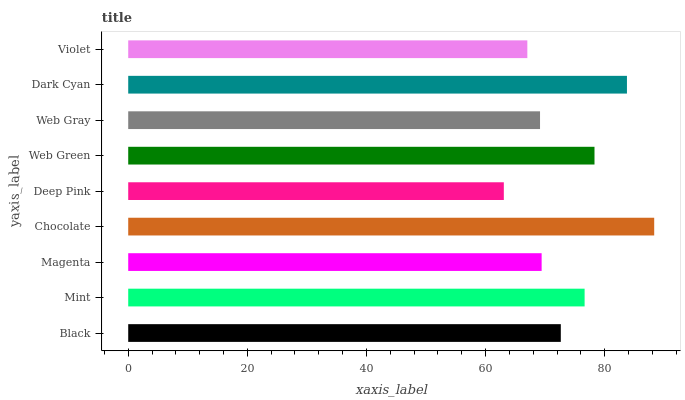Is Deep Pink the minimum?
Answer yes or no. Yes. Is Chocolate the maximum?
Answer yes or no. Yes. Is Mint the minimum?
Answer yes or no. No. Is Mint the maximum?
Answer yes or no. No. Is Mint greater than Black?
Answer yes or no. Yes. Is Black less than Mint?
Answer yes or no. Yes. Is Black greater than Mint?
Answer yes or no. No. Is Mint less than Black?
Answer yes or no. No. Is Black the high median?
Answer yes or no. Yes. Is Black the low median?
Answer yes or no. Yes. Is Deep Pink the high median?
Answer yes or no. No. Is Mint the low median?
Answer yes or no. No. 